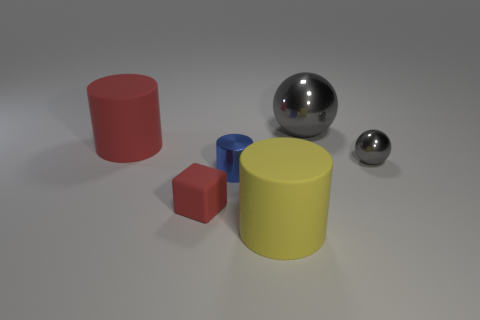What number of other things are there of the same color as the cube?
Your answer should be very brief. 1. Is the number of red rubber things to the left of the small blue cylinder greater than the number of large cylinders that are left of the large shiny object?
Make the answer very short. No. Are there any gray objects in front of the tiny red cube?
Offer a very short reply. No. The object that is both in front of the tiny blue shiny cylinder and behind the yellow cylinder is made of what material?
Offer a terse response. Rubber. There is another object that is the same shape as the small gray metallic thing; what is its color?
Keep it short and to the point. Gray. Are there any blue metal objects that are behind the red thing in front of the blue metallic thing?
Your answer should be compact. Yes. The yellow matte cylinder has what size?
Offer a terse response. Large. What is the shape of the large thing that is both behind the big yellow rubber cylinder and on the right side of the small red rubber cube?
Make the answer very short. Sphere. What number of cyan things are either metal things or large cylinders?
Keep it short and to the point. 0. There is a matte cylinder that is on the left side of the large yellow object; does it have the same size as the blue metallic thing on the right side of the small red matte thing?
Provide a succinct answer. No. 